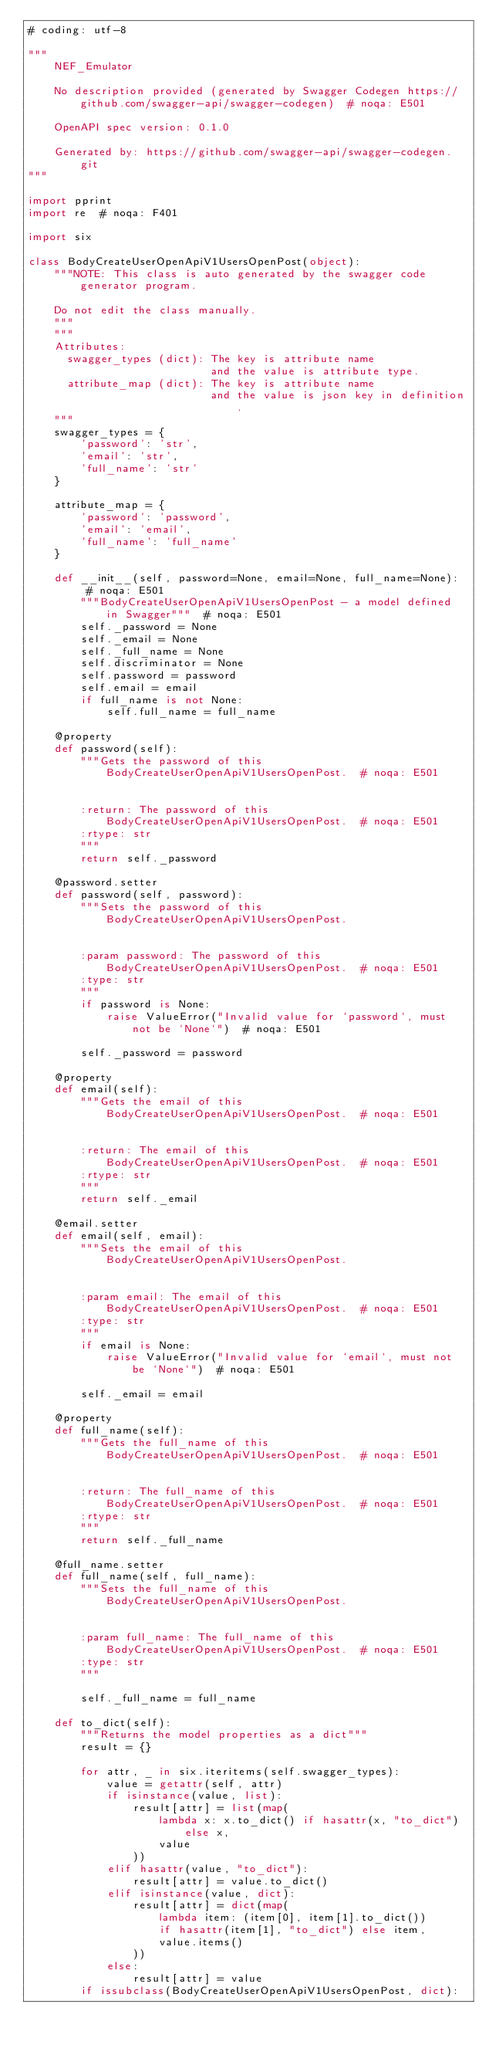Convert code to text. <code><loc_0><loc_0><loc_500><loc_500><_Python_># coding: utf-8

"""
    NEF_Emulator

    No description provided (generated by Swagger Codegen https://github.com/swagger-api/swagger-codegen)  # noqa: E501

    OpenAPI spec version: 0.1.0
    
    Generated by: https://github.com/swagger-api/swagger-codegen.git
"""

import pprint
import re  # noqa: F401

import six

class BodyCreateUserOpenApiV1UsersOpenPost(object):
    """NOTE: This class is auto generated by the swagger code generator program.

    Do not edit the class manually.
    """
    """
    Attributes:
      swagger_types (dict): The key is attribute name
                            and the value is attribute type.
      attribute_map (dict): The key is attribute name
                            and the value is json key in definition.
    """
    swagger_types = {
        'password': 'str',
        'email': 'str',
        'full_name': 'str'
    }

    attribute_map = {
        'password': 'password',
        'email': 'email',
        'full_name': 'full_name'
    }

    def __init__(self, password=None, email=None, full_name=None):  # noqa: E501
        """BodyCreateUserOpenApiV1UsersOpenPost - a model defined in Swagger"""  # noqa: E501
        self._password = None
        self._email = None
        self._full_name = None
        self.discriminator = None
        self.password = password
        self.email = email
        if full_name is not None:
            self.full_name = full_name

    @property
    def password(self):
        """Gets the password of this BodyCreateUserOpenApiV1UsersOpenPost.  # noqa: E501


        :return: The password of this BodyCreateUserOpenApiV1UsersOpenPost.  # noqa: E501
        :rtype: str
        """
        return self._password

    @password.setter
    def password(self, password):
        """Sets the password of this BodyCreateUserOpenApiV1UsersOpenPost.


        :param password: The password of this BodyCreateUserOpenApiV1UsersOpenPost.  # noqa: E501
        :type: str
        """
        if password is None:
            raise ValueError("Invalid value for `password`, must not be `None`")  # noqa: E501

        self._password = password

    @property
    def email(self):
        """Gets the email of this BodyCreateUserOpenApiV1UsersOpenPost.  # noqa: E501


        :return: The email of this BodyCreateUserOpenApiV1UsersOpenPost.  # noqa: E501
        :rtype: str
        """
        return self._email

    @email.setter
    def email(self, email):
        """Sets the email of this BodyCreateUserOpenApiV1UsersOpenPost.


        :param email: The email of this BodyCreateUserOpenApiV1UsersOpenPost.  # noqa: E501
        :type: str
        """
        if email is None:
            raise ValueError("Invalid value for `email`, must not be `None`")  # noqa: E501

        self._email = email

    @property
    def full_name(self):
        """Gets the full_name of this BodyCreateUserOpenApiV1UsersOpenPost.  # noqa: E501


        :return: The full_name of this BodyCreateUserOpenApiV1UsersOpenPost.  # noqa: E501
        :rtype: str
        """
        return self._full_name

    @full_name.setter
    def full_name(self, full_name):
        """Sets the full_name of this BodyCreateUserOpenApiV1UsersOpenPost.


        :param full_name: The full_name of this BodyCreateUserOpenApiV1UsersOpenPost.  # noqa: E501
        :type: str
        """

        self._full_name = full_name

    def to_dict(self):
        """Returns the model properties as a dict"""
        result = {}

        for attr, _ in six.iteritems(self.swagger_types):
            value = getattr(self, attr)
            if isinstance(value, list):
                result[attr] = list(map(
                    lambda x: x.to_dict() if hasattr(x, "to_dict") else x,
                    value
                ))
            elif hasattr(value, "to_dict"):
                result[attr] = value.to_dict()
            elif isinstance(value, dict):
                result[attr] = dict(map(
                    lambda item: (item[0], item[1].to_dict())
                    if hasattr(item[1], "to_dict") else item,
                    value.items()
                ))
            else:
                result[attr] = value
        if issubclass(BodyCreateUserOpenApiV1UsersOpenPost, dict):</code> 